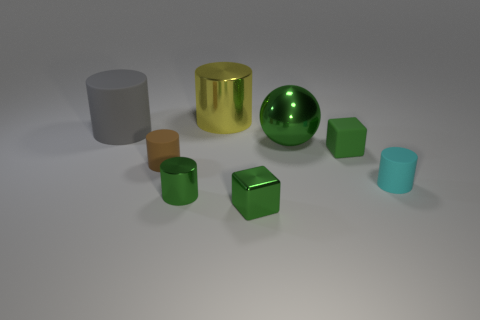Subtract all green metal cylinders. How many cylinders are left? 4 Subtract all yellow cylinders. How many cylinders are left? 4 Subtract 2 cylinders. How many cylinders are left? 3 Subtract all green cylinders. Subtract all green balls. How many cylinders are left? 4 Add 1 tiny green matte objects. How many objects exist? 9 Subtract all cylinders. How many objects are left? 3 Subtract 0 cyan balls. How many objects are left? 8 Subtract all yellow cylinders. Subtract all small brown matte things. How many objects are left? 6 Add 3 cylinders. How many cylinders are left? 8 Add 6 large red shiny cubes. How many large red shiny cubes exist? 6 